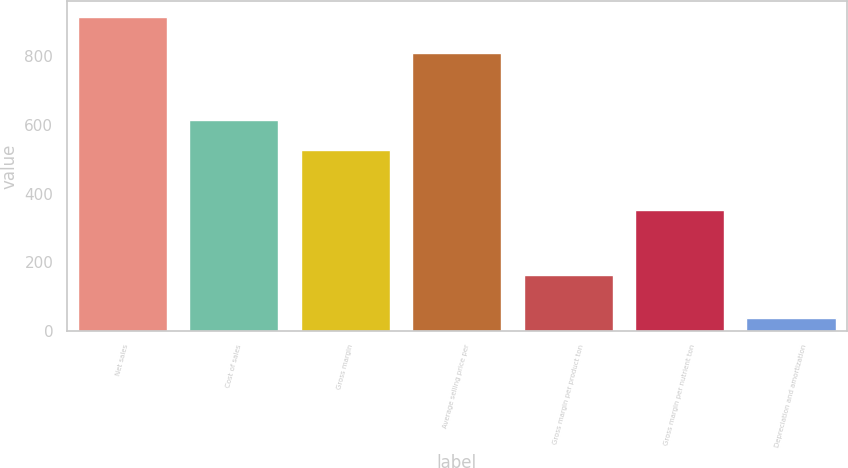Convert chart. <chart><loc_0><loc_0><loc_500><loc_500><bar_chart><fcel>Net sales<fcel>Cost of sales<fcel>Gross margin<fcel>Average selling price per<fcel>Gross margin per product ton<fcel>Gross margin per nutrient ton<fcel>Depreciation and amortization<nl><fcel>915<fcel>615.4<fcel>527.6<fcel>809<fcel>162<fcel>352<fcel>37<nl></chart> 